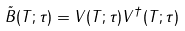<formula> <loc_0><loc_0><loc_500><loc_500>\tilde { B } ( T ; \tau ) = V ( T ; \tau ) V ^ { \dagger } ( T ; \tau )</formula> 